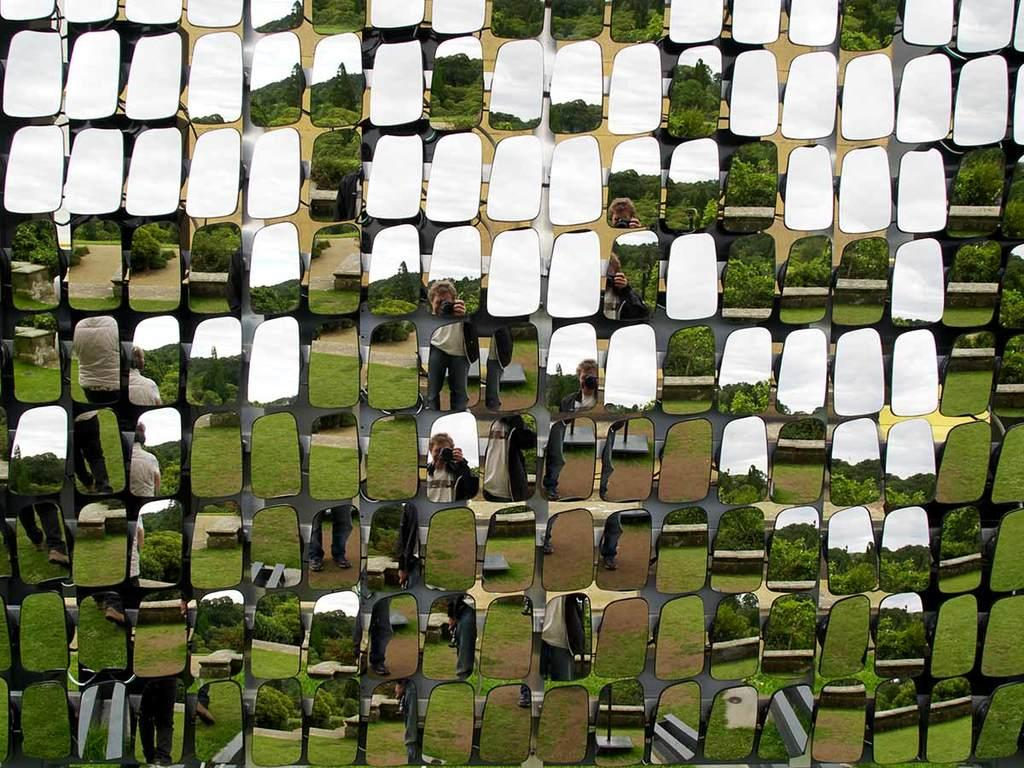What objects are present in the image? There are mirrors in the image. What can be seen on the mirrors? There are reflections visible on the mirrors. What type of feather can be seen on the vest in the image? There is no vest or feather present in the image; it only features mirrors with reflections. 